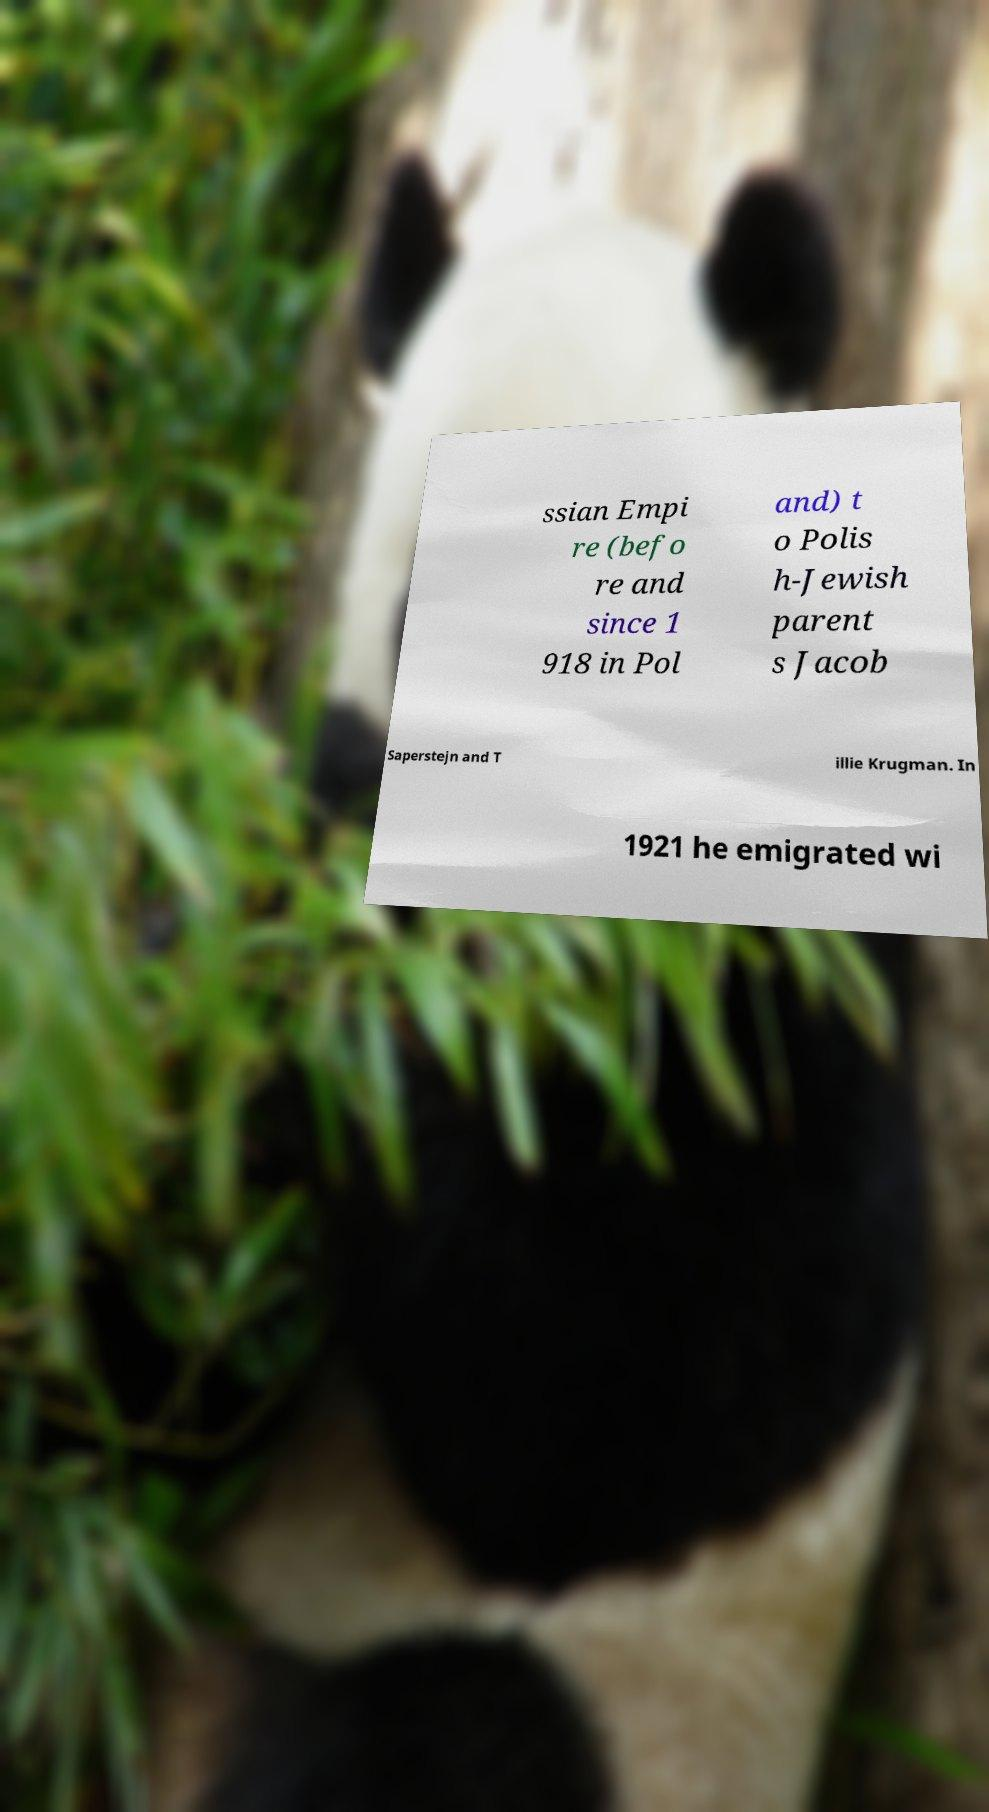Could you assist in decoding the text presented in this image and type it out clearly? ssian Empi re (befo re and since 1 918 in Pol and) t o Polis h-Jewish parent s Jacob Saperstejn and T illie Krugman. In 1921 he emigrated wi 